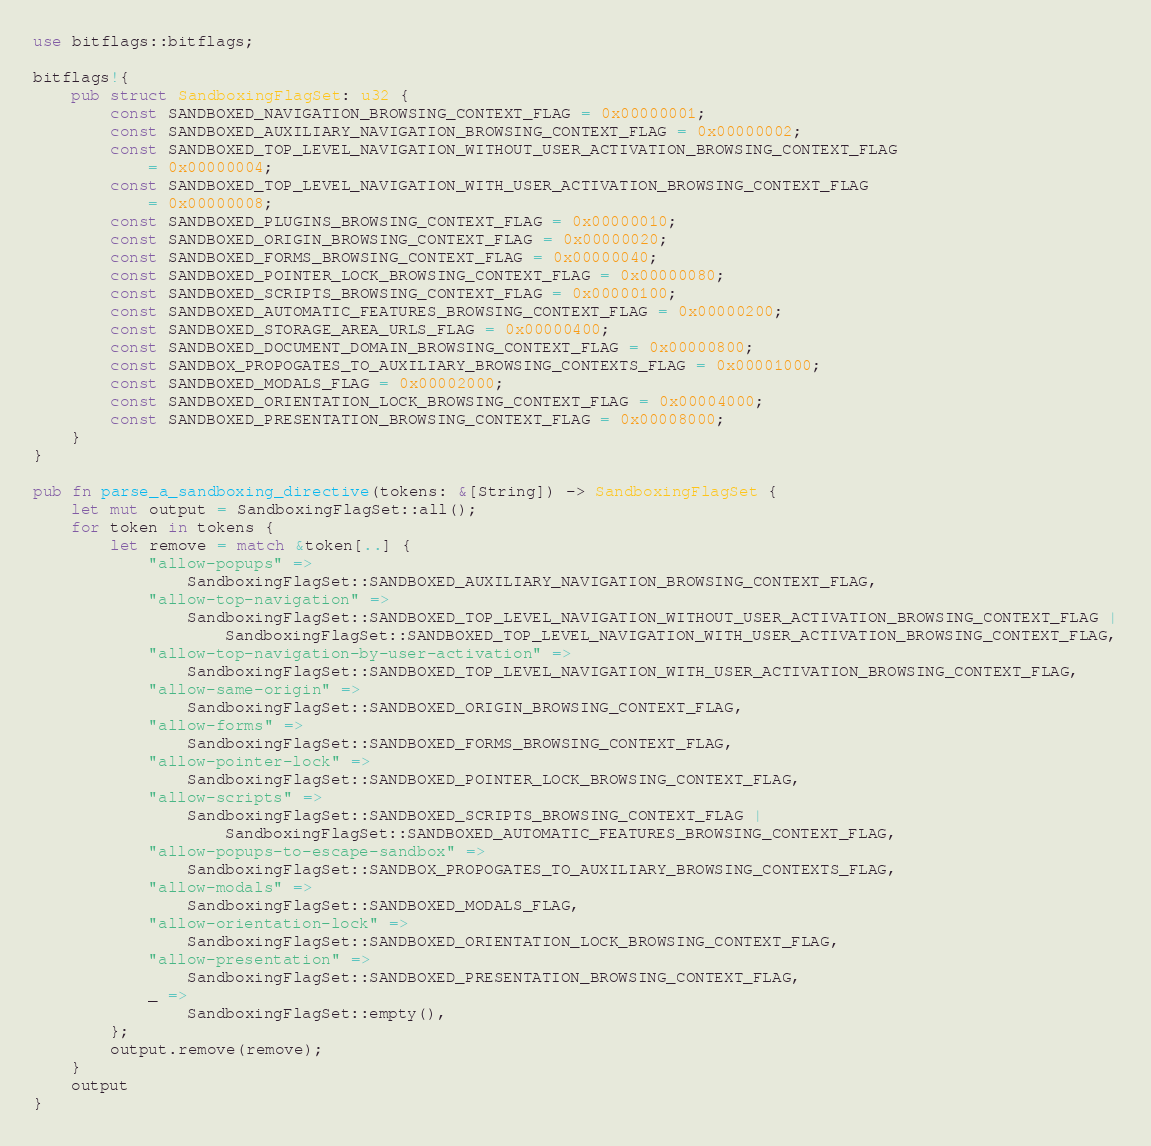Convert code to text. <code><loc_0><loc_0><loc_500><loc_500><_Rust_>use bitflags::bitflags;

bitflags!{
    pub struct SandboxingFlagSet: u32 {
        const SANDBOXED_NAVIGATION_BROWSING_CONTEXT_FLAG = 0x00000001;
        const SANDBOXED_AUXILIARY_NAVIGATION_BROWSING_CONTEXT_FLAG = 0x00000002;
        const SANDBOXED_TOP_LEVEL_NAVIGATION_WITHOUT_USER_ACTIVATION_BROWSING_CONTEXT_FLAG
            = 0x00000004;
        const SANDBOXED_TOP_LEVEL_NAVIGATION_WITH_USER_ACTIVATION_BROWSING_CONTEXT_FLAG
            = 0x00000008;
        const SANDBOXED_PLUGINS_BROWSING_CONTEXT_FLAG = 0x00000010;
        const SANDBOXED_ORIGIN_BROWSING_CONTEXT_FLAG = 0x00000020;
        const SANDBOXED_FORMS_BROWSING_CONTEXT_FLAG = 0x00000040;
        const SANDBOXED_POINTER_LOCK_BROWSING_CONTEXT_FLAG = 0x00000080;
        const SANDBOXED_SCRIPTS_BROWSING_CONTEXT_FLAG = 0x00000100;
        const SANDBOXED_AUTOMATIC_FEATURES_BROWSING_CONTEXT_FLAG = 0x00000200;
        const SANDBOXED_STORAGE_AREA_URLS_FLAG = 0x00000400;
        const SANDBOXED_DOCUMENT_DOMAIN_BROWSING_CONTEXT_FLAG = 0x00000800;
        const SANDBOX_PROPOGATES_TO_AUXILIARY_BROWSING_CONTEXTS_FLAG = 0x00001000;
        const SANDBOXED_MODALS_FLAG = 0x00002000;
        const SANDBOXED_ORIENTATION_LOCK_BROWSING_CONTEXT_FLAG = 0x00004000;
        const SANDBOXED_PRESENTATION_BROWSING_CONTEXT_FLAG = 0x00008000;
    }
}

pub fn parse_a_sandboxing_directive(tokens: &[String]) -> SandboxingFlagSet {
    let mut output = SandboxingFlagSet::all();
    for token in tokens {
        let remove = match &token[..] {
            "allow-popups" =>
                SandboxingFlagSet::SANDBOXED_AUXILIARY_NAVIGATION_BROWSING_CONTEXT_FLAG,
            "allow-top-navigation" =>
                SandboxingFlagSet::SANDBOXED_TOP_LEVEL_NAVIGATION_WITHOUT_USER_ACTIVATION_BROWSING_CONTEXT_FLAG |
                    SandboxingFlagSet::SANDBOXED_TOP_LEVEL_NAVIGATION_WITH_USER_ACTIVATION_BROWSING_CONTEXT_FLAG,
            "allow-top-navigation-by-user-activation" =>
                SandboxingFlagSet::SANDBOXED_TOP_LEVEL_NAVIGATION_WITH_USER_ACTIVATION_BROWSING_CONTEXT_FLAG,
            "allow-same-origin" =>
                SandboxingFlagSet::SANDBOXED_ORIGIN_BROWSING_CONTEXT_FLAG,
            "allow-forms" =>
                SandboxingFlagSet::SANDBOXED_FORMS_BROWSING_CONTEXT_FLAG,
            "allow-pointer-lock" =>
                SandboxingFlagSet::SANDBOXED_POINTER_LOCK_BROWSING_CONTEXT_FLAG,
            "allow-scripts" =>
                SandboxingFlagSet::SANDBOXED_SCRIPTS_BROWSING_CONTEXT_FLAG |
                    SandboxingFlagSet::SANDBOXED_AUTOMATIC_FEATURES_BROWSING_CONTEXT_FLAG,
            "allow-popups-to-escape-sandbox" =>
                SandboxingFlagSet::SANDBOX_PROPOGATES_TO_AUXILIARY_BROWSING_CONTEXTS_FLAG,
            "allow-modals" =>
                SandboxingFlagSet::SANDBOXED_MODALS_FLAG,
            "allow-orientation-lock" =>
                SandboxingFlagSet::SANDBOXED_ORIENTATION_LOCK_BROWSING_CONTEXT_FLAG,
            "allow-presentation" =>
                SandboxingFlagSet::SANDBOXED_PRESENTATION_BROWSING_CONTEXT_FLAG,
            _ =>
                SandboxingFlagSet::empty(),
        };
        output.remove(remove);
    }
    output
}
</code> 